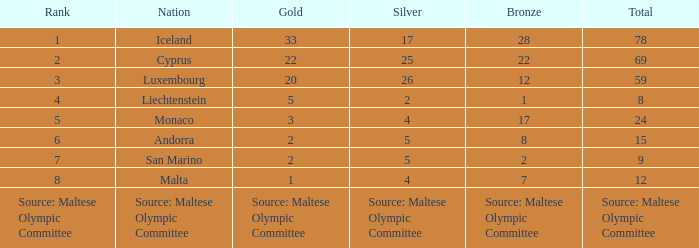What is the number of gold medals when the number of bronze medals is 8? 2.0. 